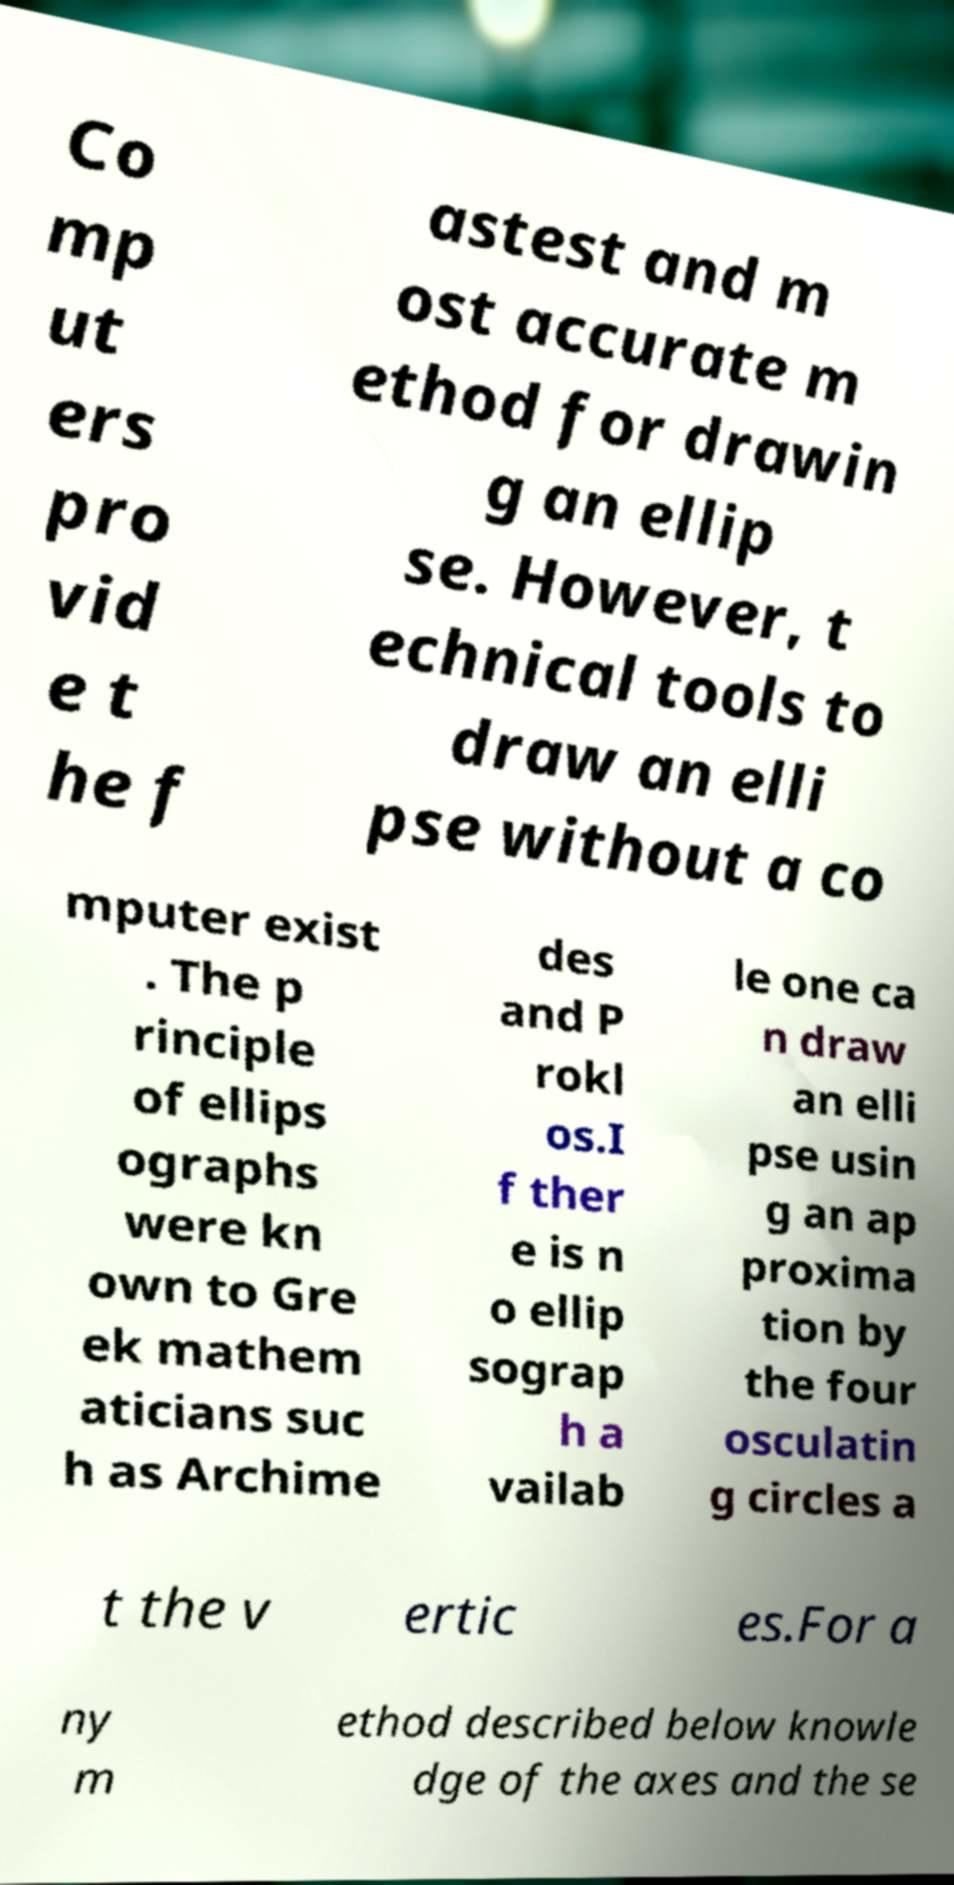What messages or text are displayed in this image? I need them in a readable, typed format. Co mp ut ers pro vid e t he f astest and m ost accurate m ethod for drawin g an ellip se. However, t echnical tools to draw an elli pse without a co mputer exist . The p rinciple of ellips ographs were kn own to Gre ek mathem aticians suc h as Archime des and P rokl os.I f ther e is n o ellip sograp h a vailab le one ca n draw an elli pse usin g an ap proxima tion by the four osculatin g circles a t the v ertic es.For a ny m ethod described below knowle dge of the axes and the se 